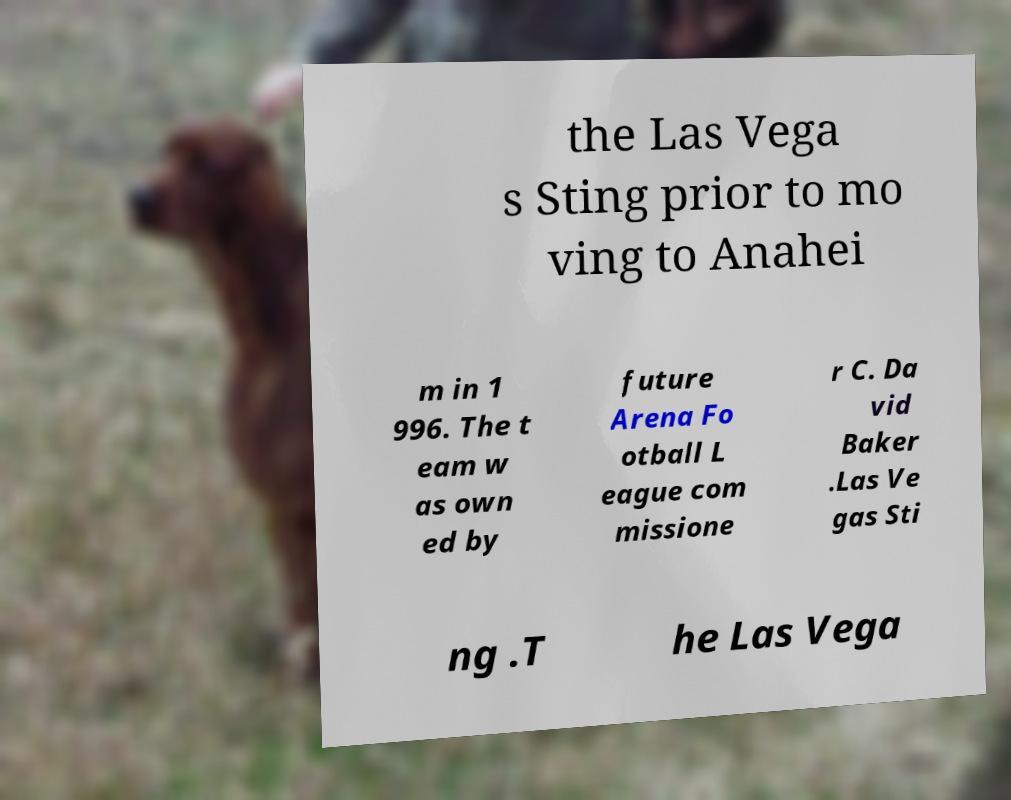There's text embedded in this image that I need extracted. Can you transcribe it verbatim? the Las Vega s Sting prior to mo ving to Anahei m in 1 996. The t eam w as own ed by future Arena Fo otball L eague com missione r C. Da vid Baker .Las Ve gas Sti ng .T he Las Vega 